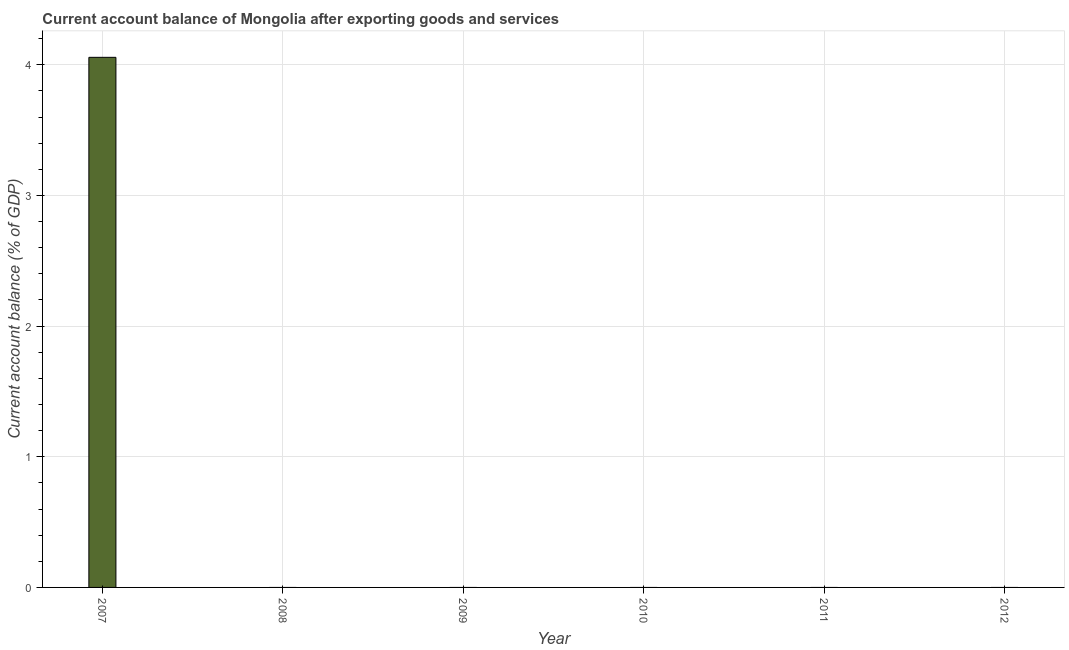Does the graph contain grids?
Your answer should be very brief. Yes. What is the title of the graph?
Ensure brevity in your answer.  Current account balance of Mongolia after exporting goods and services. What is the label or title of the X-axis?
Offer a terse response. Year. What is the label or title of the Y-axis?
Make the answer very short. Current account balance (% of GDP). What is the current account balance in 2009?
Your answer should be compact. 0. Across all years, what is the maximum current account balance?
Offer a very short reply. 4.06. What is the sum of the current account balance?
Provide a succinct answer. 4.06. What is the average current account balance per year?
Provide a succinct answer. 0.68. What is the median current account balance?
Keep it short and to the point. 0. What is the difference between the highest and the lowest current account balance?
Give a very brief answer. 4.06. In how many years, is the current account balance greater than the average current account balance taken over all years?
Make the answer very short. 1. How many years are there in the graph?
Your answer should be very brief. 6. Are the values on the major ticks of Y-axis written in scientific E-notation?
Provide a succinct answer. No. What is the Current account balance (% of GDP) of 2007?
Offer a terse response. 4.06. What is the Current account balance (% of GDP) in 2008?
Provide a short and direct response. 0. What is the Current account balance (% of GDP) of 2009?
Ensure brevity in your answer.  0. 